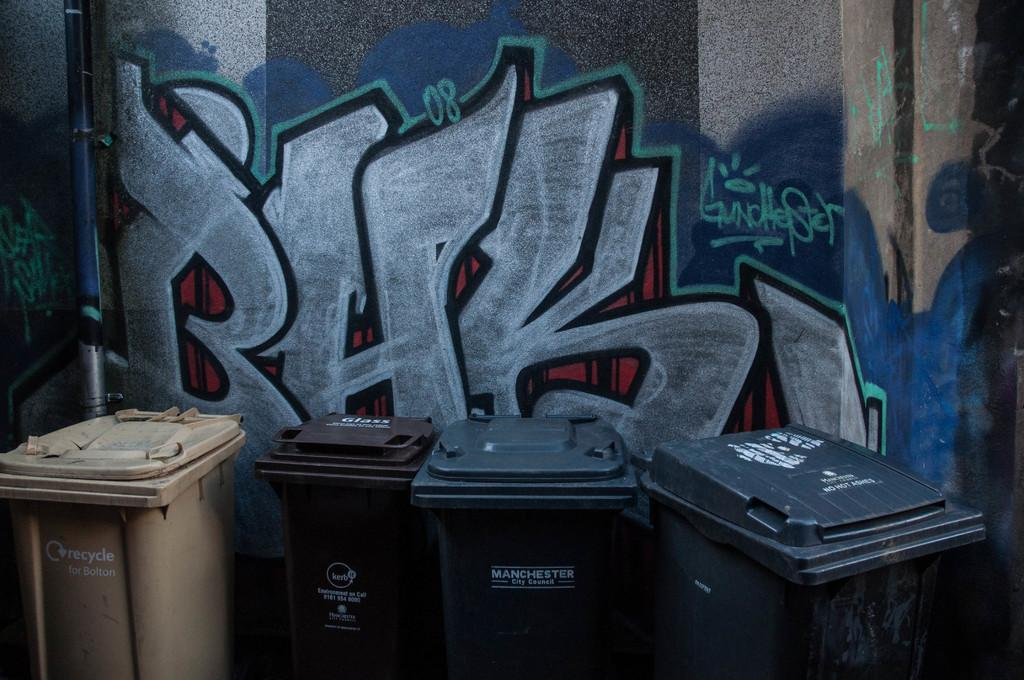<image>
Give a short and clear explanation of the subsequent image. The displayed trashcans are picked up by the city of Manchester. 